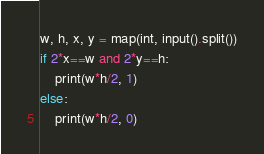<code> <loc_0><loc_0><loc_500><loc_500><_Python_>w, h, x, y = map(int, input().split())
if 2*x==w and 2*y==h:
    print(w*h/2, 1)
else:
    print(w*h/2, 0)</code> 